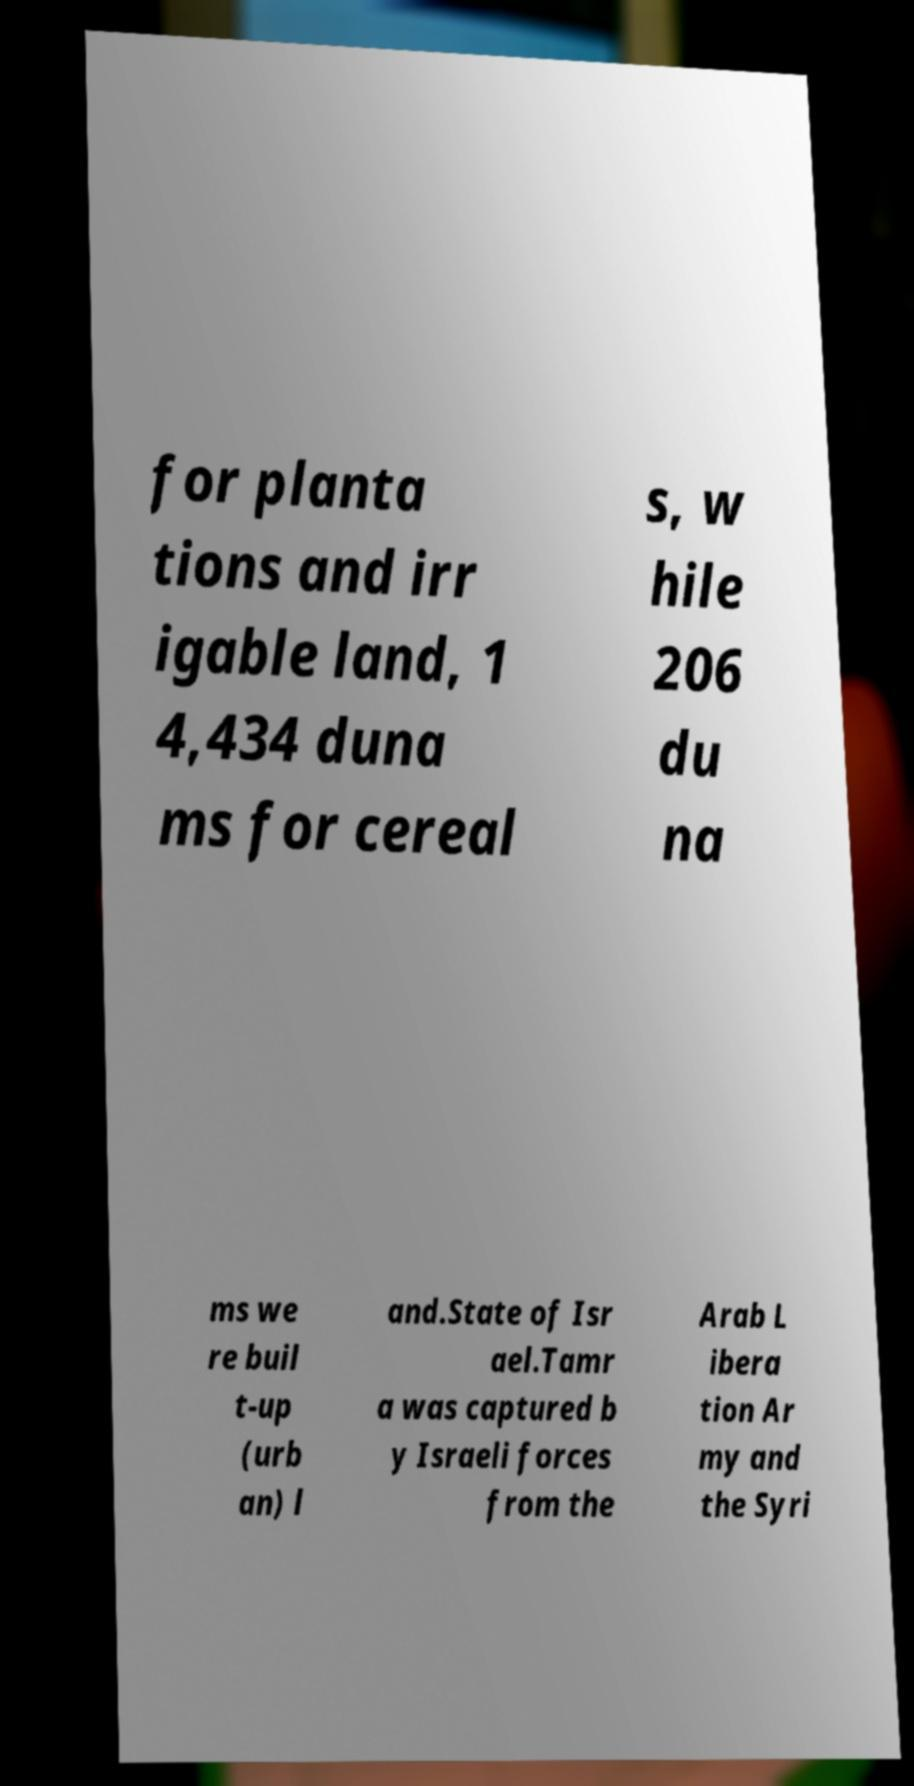Can you read and provide the text displayed in the image?This photo seems to have some interesting text. Can you extract and type it out for me? for planta tions and irr igable land, 1 4,434 duna ms for cereal s, w hile 206 du na ms we re buil t-up (urb an) l and.State of Isr ael.Tamr a was captured b y Israeli forces from the Arab L ibera tion Ar my and the Syri 